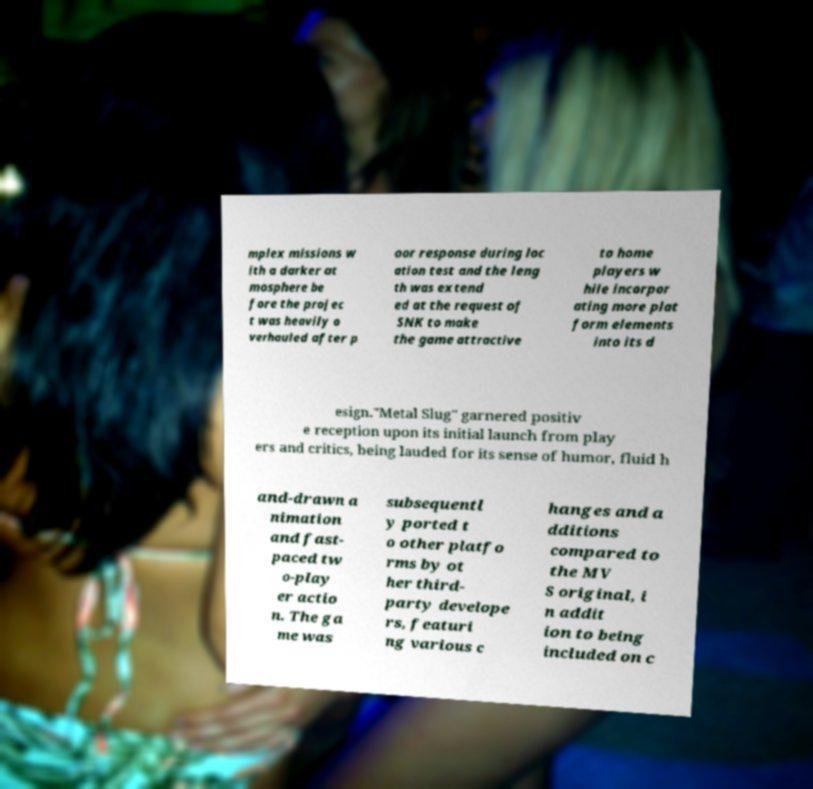Could you extract and type out the text from this image? mplex missions w ith a darker at mosphere be fore the projec t was heavily o verhauled after p oor response during loc ation test and the leng th was extend ed at the request of SNK to make the game attractive to home players w hile incorpor ating more plat form elements into its d esign."Metal Slug" garnered positiv e reception upon its initial launch from play ers and critics, being lauded for its sense of humor, fluid h and-drawn a nimation and fast- paced tw o-play er actio n. The ga me was subsequentl y ported t o other platfo rms by ot her third- party develope rs, featuri ng various c hanges and a dditions compared to the MV S original, i n addit ion to being included on c 